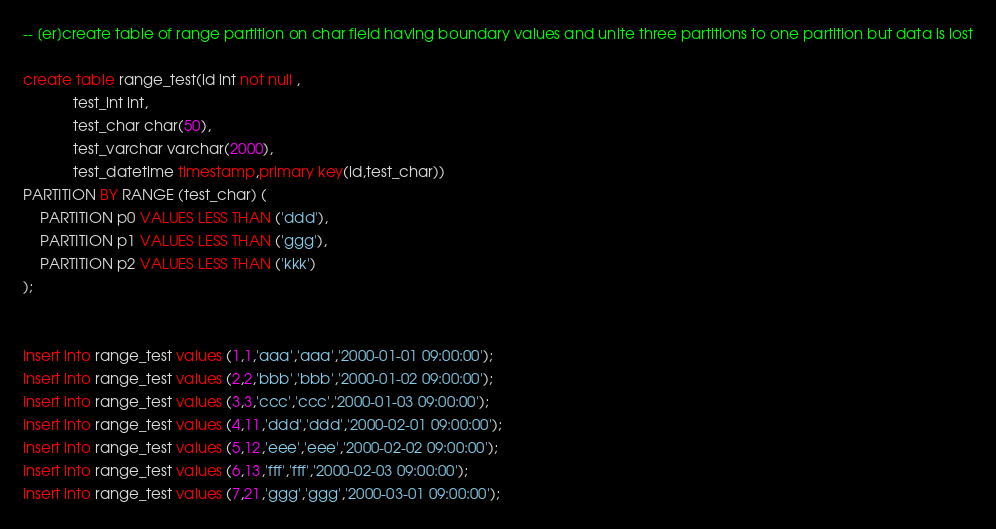<code> <loc_0><loc_0><loc_500><loc_500><_SQL_>-- [er]create table of range partition on char field having boundary values and unite three partitions to one partition but data is lost

create table range_test(id int not null ,
			test_int int,
			test_char char(50),
			test_varchar varchar(2000),
			test_datetime timestamp,primary key(id,test_char))
PARTITION BY RANGE (test_char) (
    PARTITION p0 VALUES LESS THAN ('ddd'),
    PARTITION p1 VALUES LESS THAN ('ggg'),
    PARTITION p2 VALUES LESS THAN ('kkk')
);


insert into range_test values (1,1,'aaa','aaa','2000-01-01 09:00:00');
insert into range_test values (2,2,'bbb','bbb','2000-01-02 09:00:00');
insert into range_test values (3,3,'ccc','ccc','2000-01-03 09:00:00');
insert into range_test values (4,11,'ddd','ddd','2000-02-01 09:00:00');
insert into range_test values (5,12,'eee','eee','2000-02-02 09:00:00');
insert into range_test values (6,13,'fff','fff','2000-02-03 09:00:00');
insert into range_test values (7,21,'ggg','ggg','2000-03-01 09:00:00');</code> 